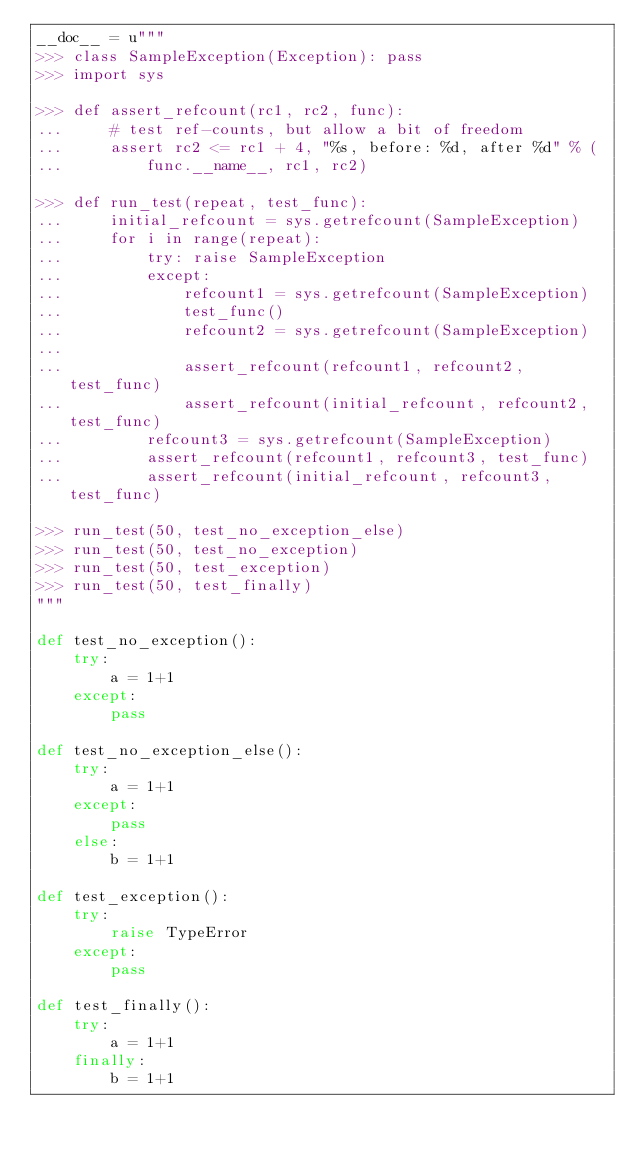Convert code to text. <code><loc_0><loc_0><loc_500><loc_500><_Cython_>__doc__ = u"""
>>> class SampleException(Exception): pass
>>> import sys

>>> def assert_refcount(rc1, rc2, func):
...     # test ref-counts, but allow a bit of freedom
...     assert rc2 <= rc1 + 4, "%s, before: %d, after %d" % (
...         func.__name__, rc1, rc2)

>>> def run_test(repeat, test_func):
...     initial_refcount = sys.getrefcount(SampleException)
...     for i in range(repeat):
...         try: raise SampleException
...         except:
...             refcount1 = sys.getrefcount(SampleException)
...             test_func()
...             refcount2 = sys.getrefcount(SampleException)
...
...             assert_refcount(refcount1, refcount2, test_func)
...             assert_refcount(initial_refcount, refcount2, test_func)
...         refcount3 = sys.getrefcount(SampleException)
...         assert_refcount(refcount1, refcount3, test_func)
...         assert_refcount(initial_refcount, refcount3, test_func)

>>> run_test(50, test_no_exception_else)
>>> run_test(50, test_no_exception)
>>> run_test(50, test_exception)
>>> run_test(50, test_finally)
"""

def test_no_exception():
    try:
        a = 1+1
    except:
        pass

def test_no_exception_else():
    try:
        a = 1+1
    except:
        pass
    else:
        b = 1+1

def test_exception():
    try:
        raise TypeError
    except:
        pass

def test_finally():
    try:
        a = 1+1
    finally:
        b = 1+1
</code> 